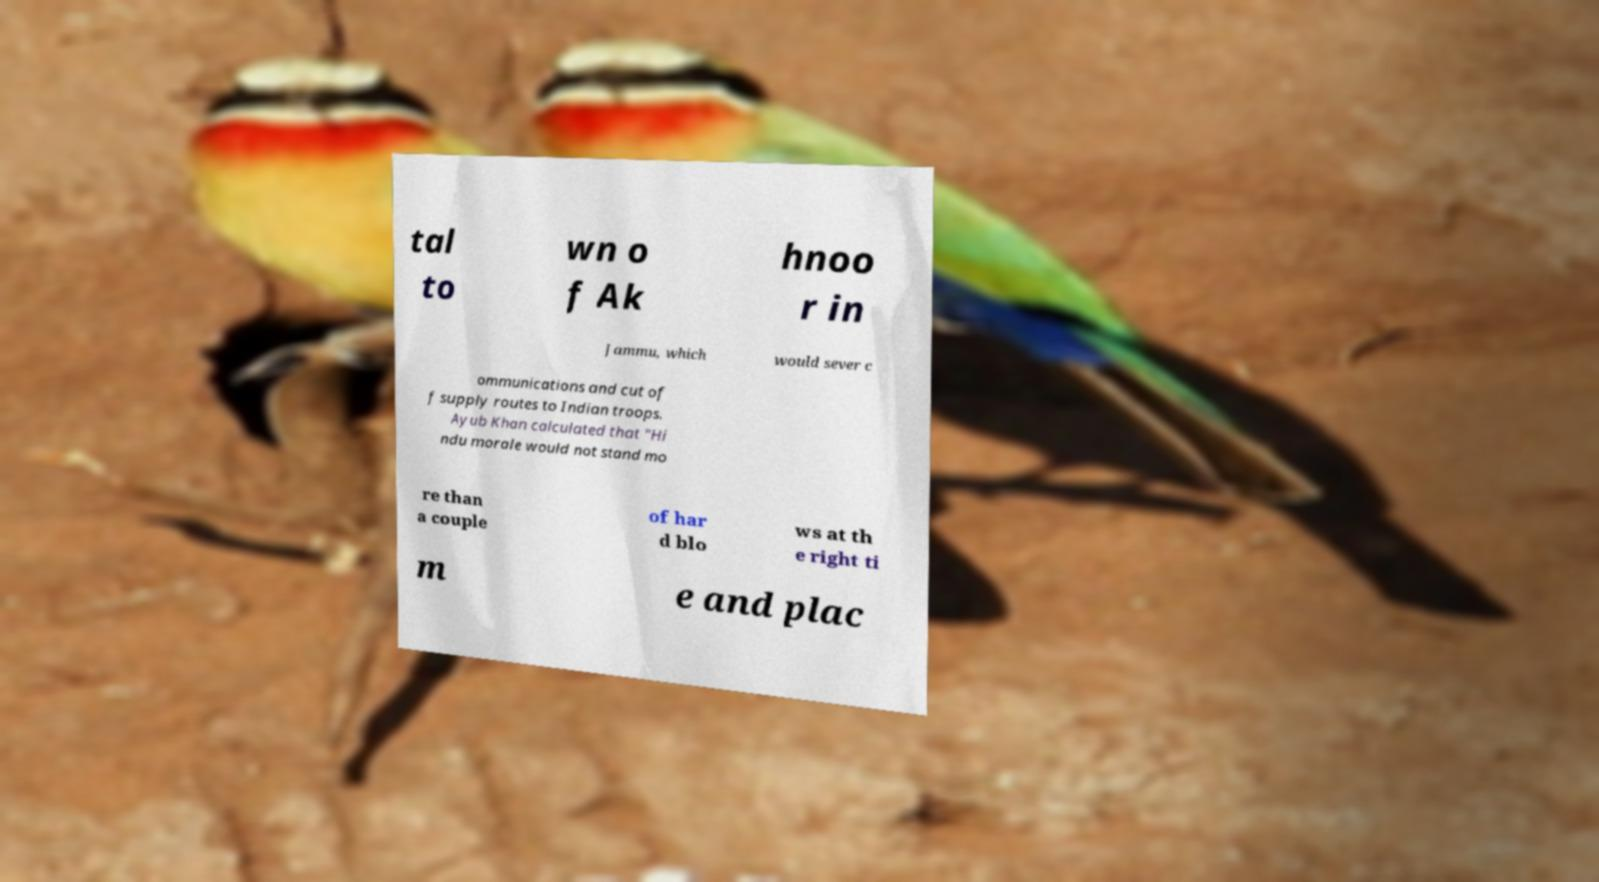Could you assist in decoding the text presented in this image and type it out clearly? tal to wn o f Ak hnoo r in Jammu, which would sever c ommunications and cut of f supply routes to Indian troops. Ayub Khan calculated that "Hi ndu morale would not stand mo re than a couple of har d blo ws at th e right ti m e and plac 